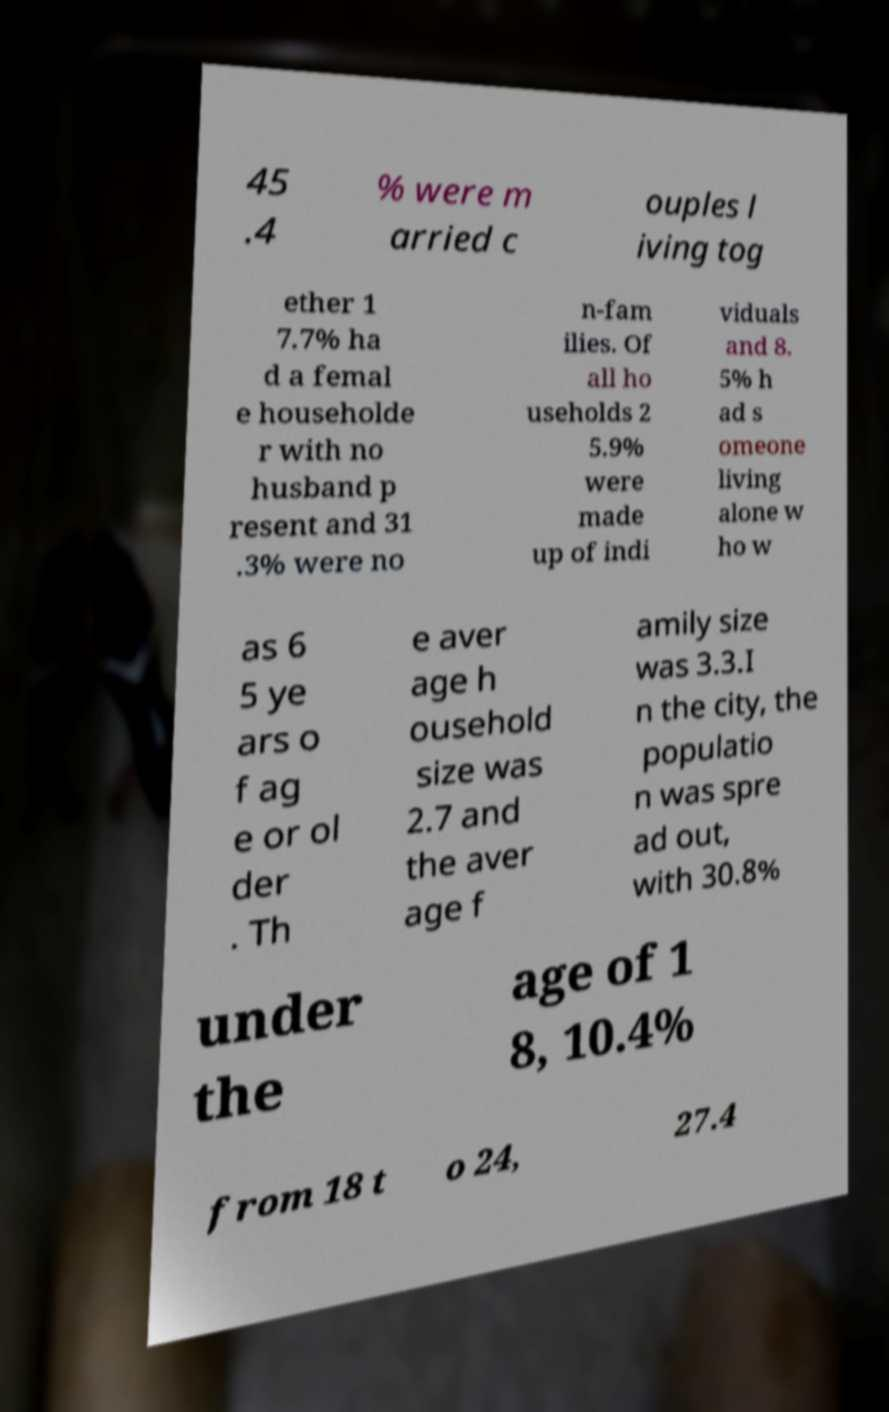Could you assist in decoding the text presented in this image and type it out clearly? 45 .4 % were m arried c ouples l iving tog ether 1 7.7% ha d a femal e householde r with no husband p resent and 31 .3% were no n-fam ilies. Of all ho useholds 2 5.9% were made up of indi viduals and 8. 5% h ad s omeone living alone w ho w as 6 5 ye ars o f ag e or ol der . Th e aver age h ousehold size was 2.7 and the aver age f amily size was 3.3.I n the city, the populatio n was spre ad out, with 30.8% under the age of 1 8, 10.4% from 18 t o 24, 27.4 